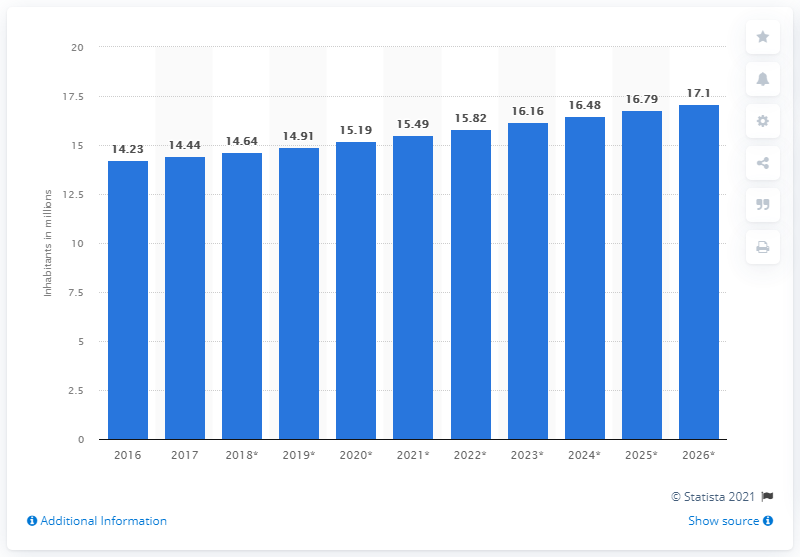Highlight a few significant elements in this photo. The population of Zimbabwe in 2019 was 14.91 million. 